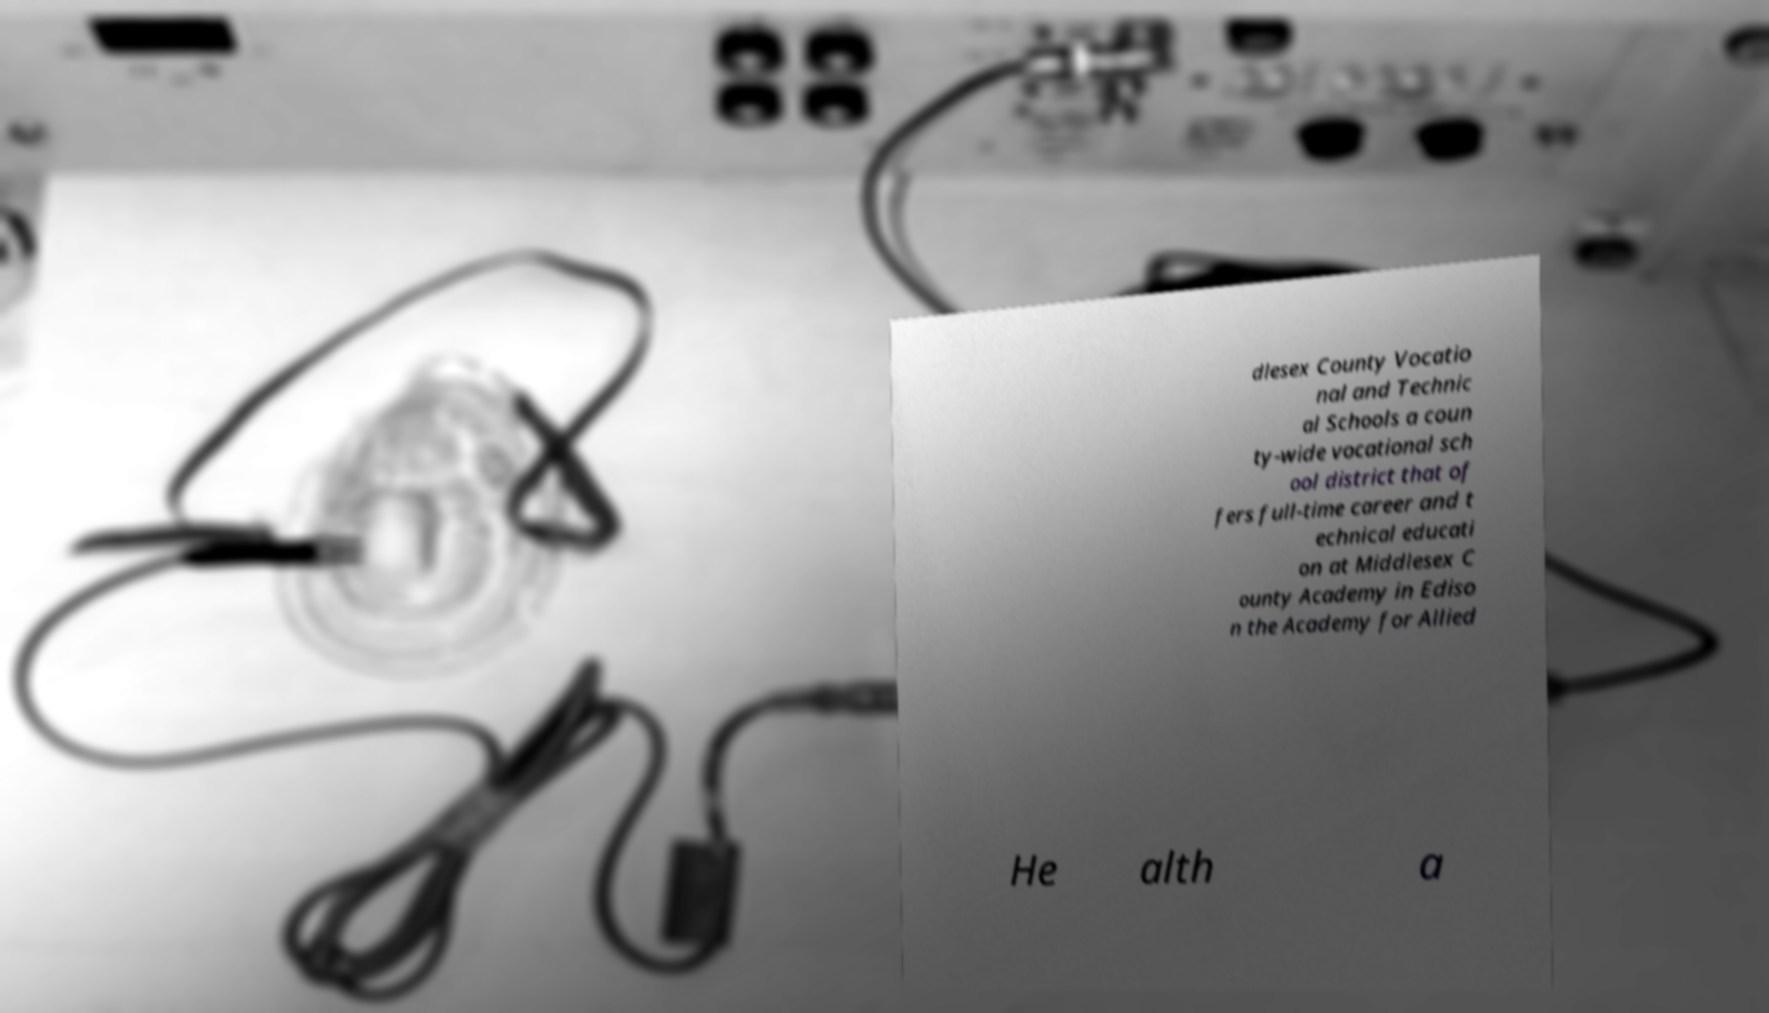There's text embedded in this image that I need extracted. Can you transcribe it verbatim? dlesex County Vocatio nal and Technic al Schools a coun ty-wide vocational sch ool district that of fers full-time career and t echnical educati on at Middlesex C ounty Academy in Ediso n the Academy for Allied He alth a 